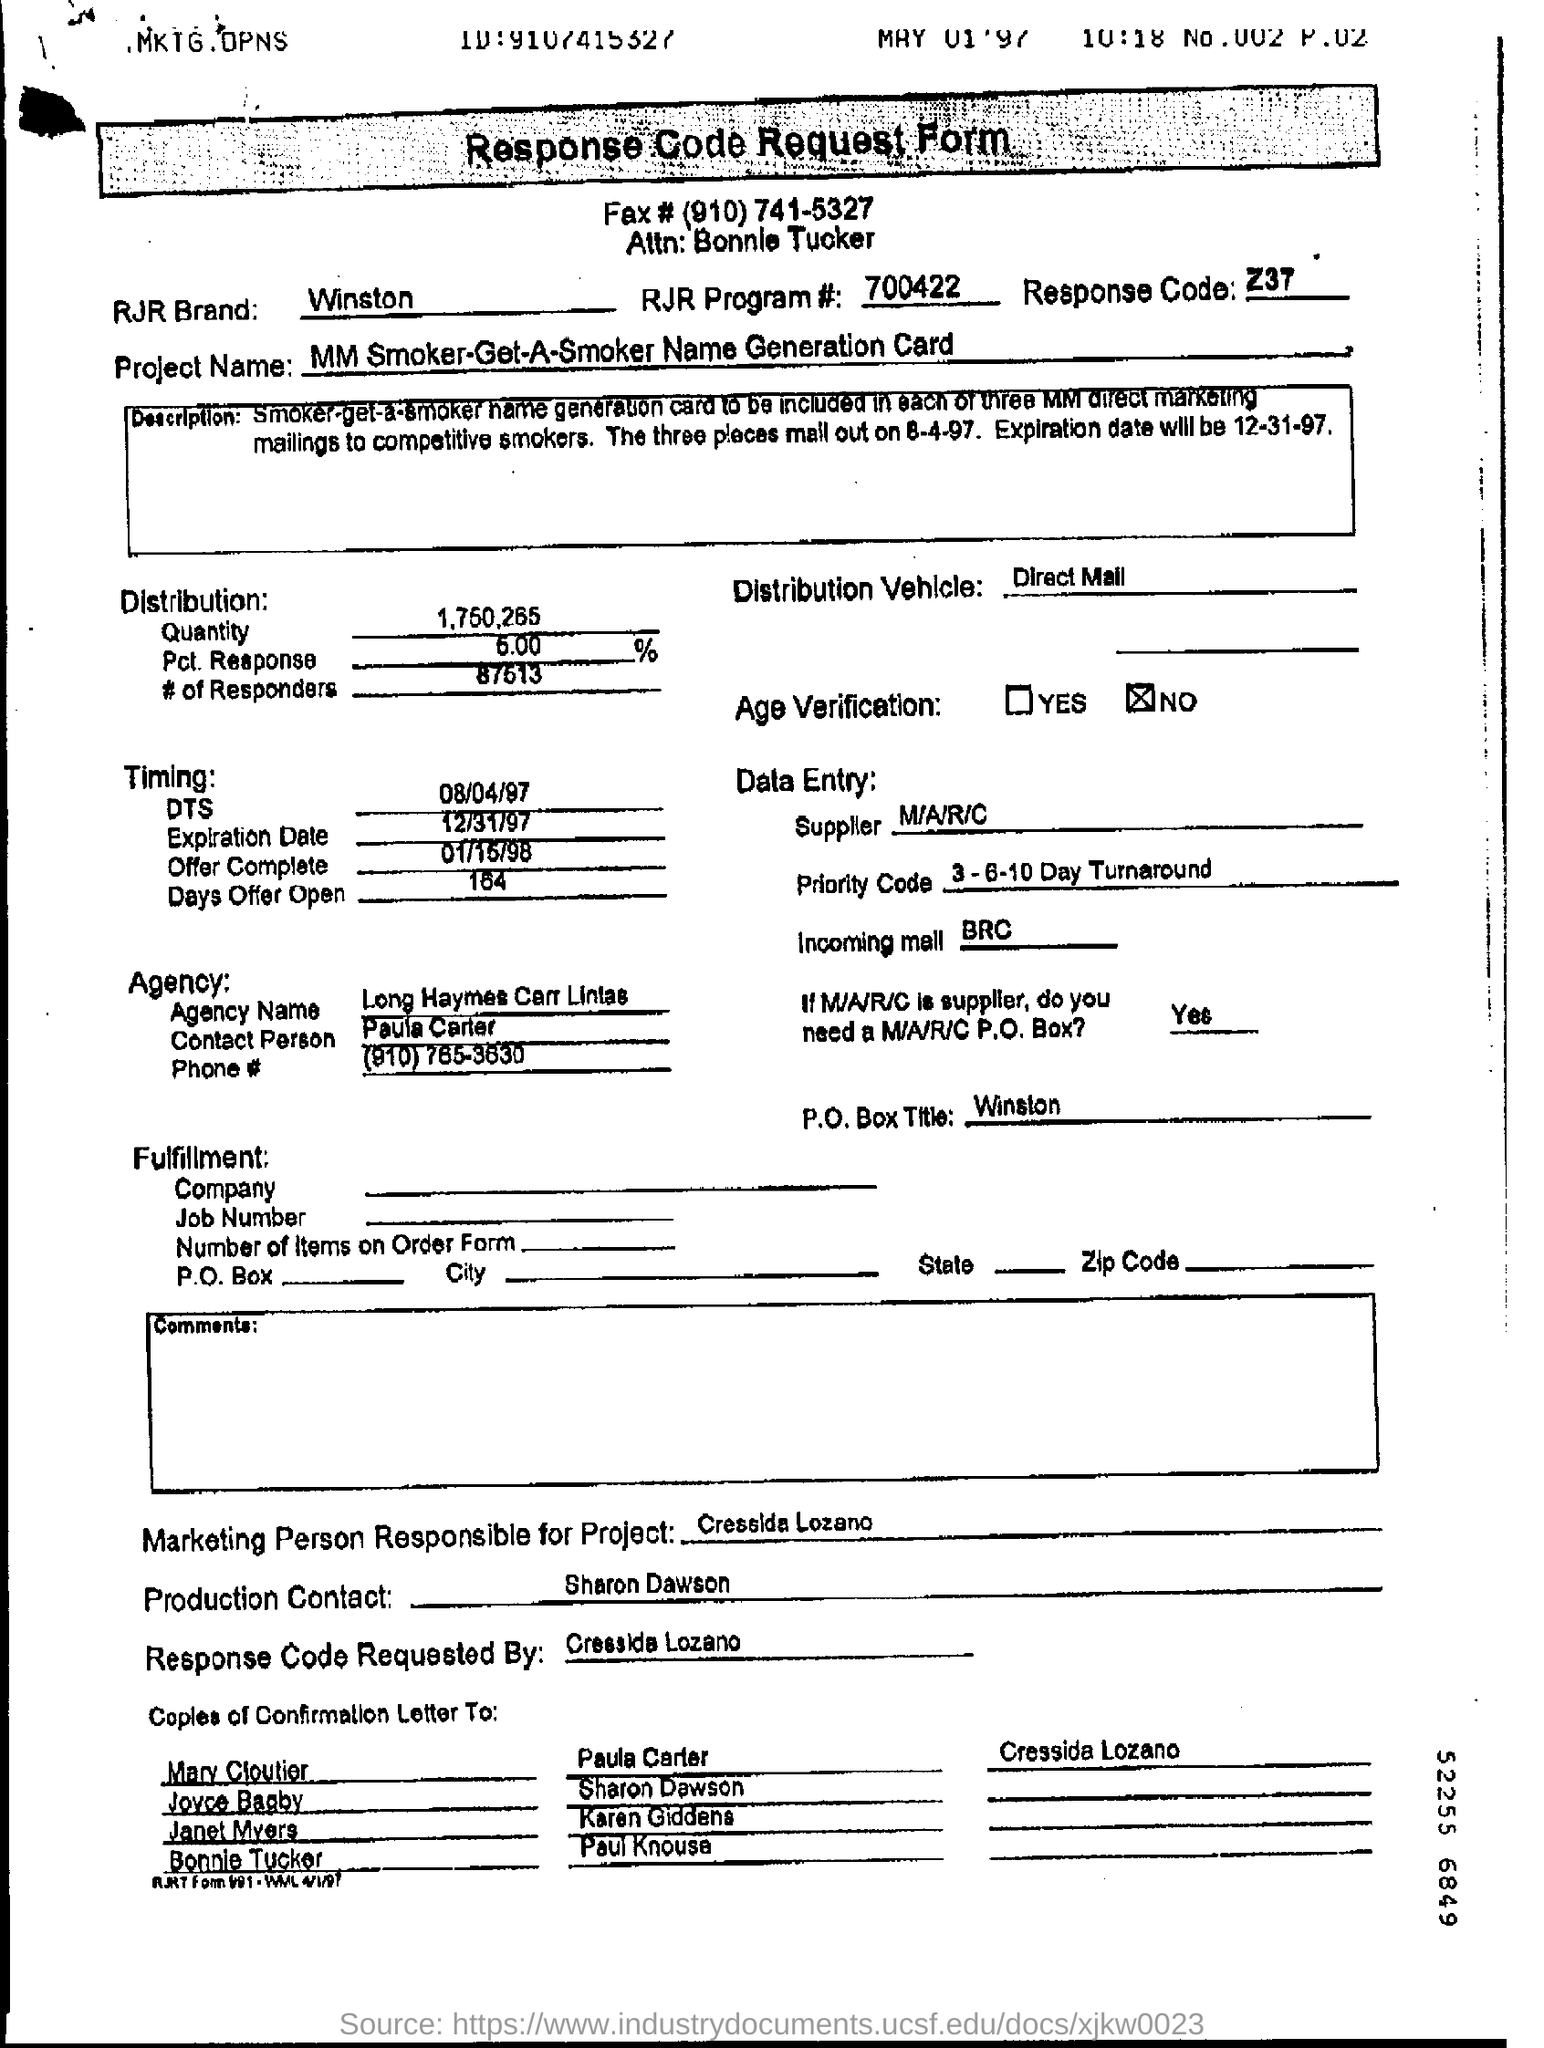Identify some key points in this picture. The response code mentioned in the form is Z37. 